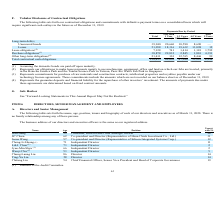According to United Micro Electronics's financial document, What are the obligations to make lease payments? obligations to make lease payments mainly to use machineries, equipment, office and land on which our fabs are located. The document states: "ds are paid off upon maturity. (2) Represents our obligations to make lease payments mainly to use machineries, equipment, office and land on which ou..." Also, can you calculate: What is average of loans? Based on the calculation: 51,058 / 4, the result is 12764.5 (in millions). This is based on the information: "nsecured bonds 39,940 20,660 10,590 8,690 — Loans 51,058 18,316 19,632 13,098 12 Lease obligations (2) 7,128 741 1,414 1,181 3,792 Purchase obligations (3) nsecured bonds 39,940 20,660 10,590 8,690 — ..." The key data points involved are: 51,058. Also, can you calculate: What is the average lease obligation for the period Less than 1 Year and 1-3 Years? To answer this question, I need to perform calculations using the financial data. The calculation is: (741+1,414) / 2, which equals 1077.5 (in millions). This is based on the information: "19,632 13,098 12 Lease obligations (2) 7,128 741 1,414 1,181 3,792 Purchase obligations (3) 38,878 29,832 2,845 1,810 4,391 Other long-term obligations (4 ,316 19,632 13,098 12 Lease obligations (2) 7..." The key data points involved are: 1,414, 741. Also, can you calculate: What is the average of total contractual cash obligations? Based on the calculation: 158,415 / 4, the result is 39603.75 (in millions). This is based on the information: "2,765 8,446 99 Total contractual cash obligations 158,415 69,650 47,246 33,225 8,294 2,765 8,446 99 Total contractual cash obligations 158,415 69,650 47,246 33,225 8,294..." The key data points involved are: 158,415, 4. Also, What does Purchase obligations incorporate? Represents commitments for purchase of raw materials and construction contracts, intellectual properties and royalties payable under our technology license agreements.. The document states: "Taiwan, Pasir Ris Wafer Fab Park in Singapore. (3) Represents commitments for purchase of raw materials and construction contracts, intellectual prope..." Also, What does other long-term obligation include? Represents the guarantee deposits and financial liability for the repurchase of other investors’ investment. The document states: "on our balance sheet as of December 31, 2019. (4) Represents the guarantee deposits and financial liability for the repurchase of other investors’ inv..." 